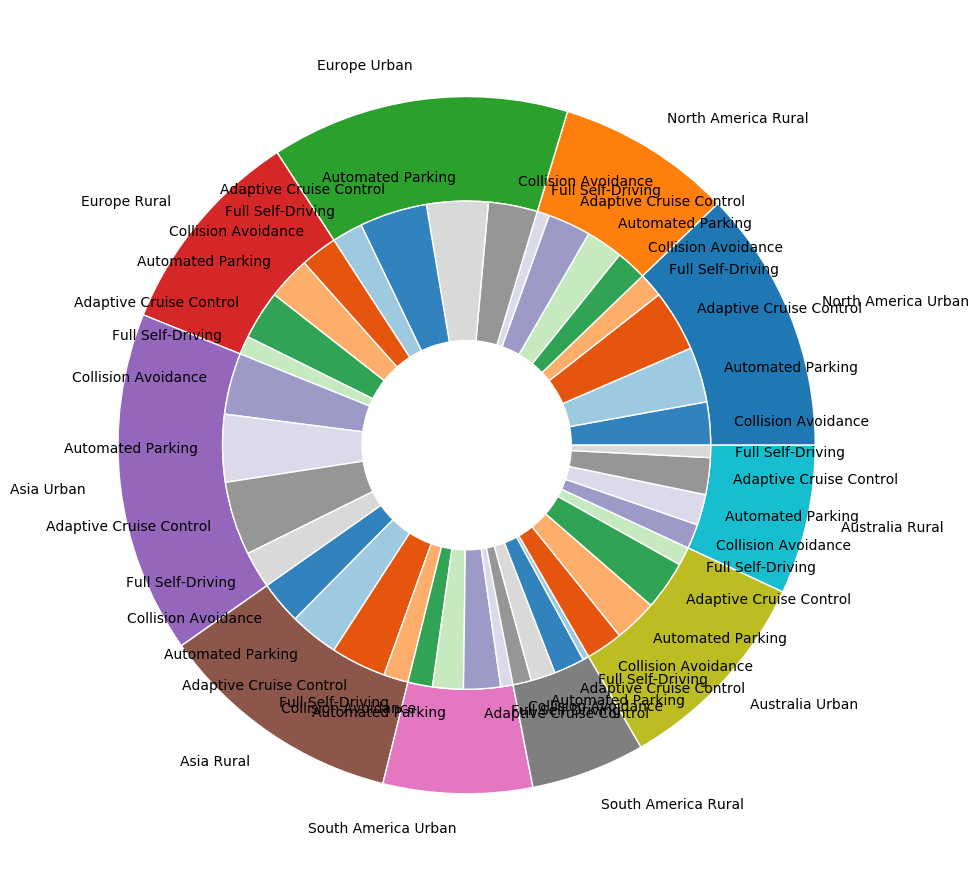What's the total adoption rate for Collision Avoidance technology in North America? To find the total adoption rate for Collision Avoidance technology in North America, sum the adoption rates for both urban and rural areas: 35 (urban) + 25 (rural) = 60.
Answer: 60 Which region has the highest adoption rate for Full Self-Driving technology in rural areas? Compare the adoption rates for Full Self-Driving in rural areas across all regions: North America (10), Europe (15), Asia (20), South America (5), Australia (10). Asia has the highest at 20.
Answer: Asia How does the adoption rate of Automated Parking technology in urban areas of Europe compare to that in North America? Automated Parking in urban Europe has an adoption rate of 50, while in urban North America, it is 45. Thus, Europe has a higher adoption rate by 5.
Answer: Europe, 5 What is the combined adoption rate for Adaptive Cruise Control and Full Self-Driving technologies in urban Australia? In urban Australia, the adoption rates are 40 for Adaptive Cruise Control and 15 for Full Self-Driving. Combined, they are 40 + 15 = 55.
Answer: 55 In Asia's urban areas, which technology has the lowest adoption rate? Review the adoption rates for Asia's urban areas: Collision Avoidance (50), Automated Parking (55), Adaptive Cruise Control (60), Full Self-Driving (30). Full Self-Driving has the lowest rate at 30.
Answer: Full Self-Driving Which area (urban or rural) in South America has a higher adoption rate for Collision Avoidance technology? Compare the Collision Avoidance adoption rates in South America: Urban (20), Rural (15). Urban areas have a higher rate by 5.
Answer: Urban, 5 What is the difference in the adoption rate of Adaptive Cruise Control between rural Europe and rural South America? The adoption rate for Adaptive Cruise Control in rural Europe is 40, and in rural South America, it is 25. The difference is 40 - 25 = 15.
Answer: 15 Is the adoption rate of Full Self-Driving technology higher in urban North America or rural Europe? In urban North America, the adoption rate is 20, while in rural Europe it is 15. Urban North America has a higher rate by 5.
Answer: Urban North America, 5 What’s the average adoption rate of Collision Avoidance technology across all regions? Sum the adoption rates of Collision Avoidance for all regions and divide by the number of regions. (35 + 25 + 40 + 30 + 50 + 35 + 20 + 15 + 30 + 20) / 5 = 300 / 5 = 60
Answer: 60 